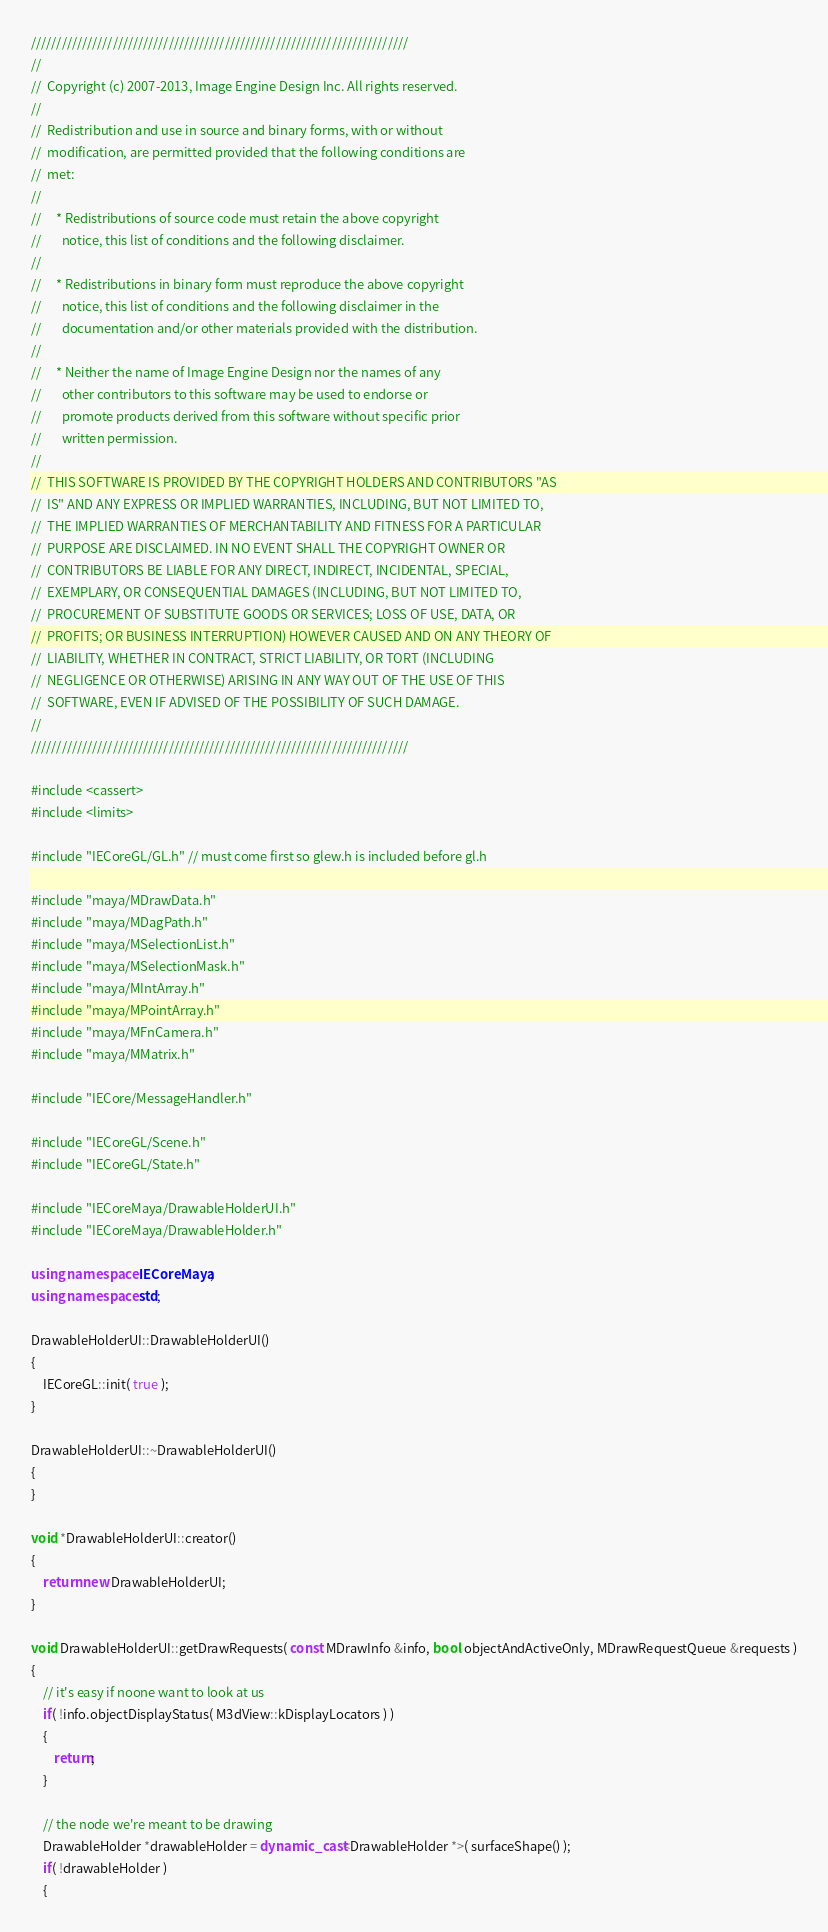<code> <loc_0><loc_0><loc_500><loc_500><_C++_>//////////////////////////////////////////////////////////////////////////
//
//  Copyright (c) 2007-2013, Image Engine Design Inc. All rights reserved.
//
//  Redistribution and use in source and binary forms, with or without
//  modification, are permitted provided that the following conditions are
//  met:
//
//     * Redistributions of source code must retain the above copyright
//       notice, this list of conditions and the following disclaimer.
//
//     * Redistributions in binary form must reproduce the above copyright
//       notice, this list of conditions and the following disclaimer in the
//       documentation and/or other materials provided with the distribution.
//
//     * Neither the name of Image Engine Design nor the names of any
//       other contributors to this software may be used to endorse or
//       promote products derived from this software without specific prior
//       written permission.
//
//  THIS SOFTWARE IS PROVIDED BY THE COPYRIGHT HOLDERS AND CONTRIBUTORS "AS
//  IS" AND ANY EXPRESS OR IMPLIED WARRANTIES, INCLUDING, BUT NOT LIMITED TO,
//  THE IMPLIED WARRANTIES OF MERCHANTABILITY AND FITNESS FOR A PARTICULAR
//  PURPOSE ARE DISCLAIMED. IN NO EVENT SHALL THE COPYRIGHT OWNER OR
//  CONTRIBUTORS BE LIABLE FOR ANY DIRECT, INDIRECT, INCIDENTAL, SPECIAL,
//  EXEMPLARY, OR CONSEQUENTIAL DAMAGES (INCLUDING, BUT NOT LIMITED TO,
//  PROCUREMENT OF SUBSTITUTE GOODS OR SERVICES; LOSS OF USE, DATA, OR
//  PROFITS; OR BUSINESS INTERRUPTION) HOWEVER CAUSED AND ON ANY THEORY OF
//  LIABILITY, WHETHER IN CONTRACT, STRICT LIABILITY, OR TORT (INCLUDING
//  NEGLIGENCE OR OTHERWISE) ARISING IN ANY WAY OUT OF THE USE OF THIS
//  SOFTWARE, EVEN IF ADVISED OF THE POSSIBILITY OF SUCH DAMAGE.
//
//////////////////////////////////////////////////////////////////////////

#include <cassert>
#include <limits>

#include "IECoreGL/GL.h" // must come first so glew.h is included before gl.h

#include "maya/MDrawData.h"
#include "maya/MDagPath.h"
#include "maya/MSelectionList.h"
#include "maya/MSelectionMask.h"
#include "maya/MIntArray.h"
#include "maya/MPointArray.h"
#include "maya/MFnCamera.h"
#include "maya/MMatrix.h"

#include "IECore/MessageHandler.h"

#include "IECoreGL/Scene.h"
#include "IECoreGL/State.h"

#include "IECoreMaya/DrawableHolderUI.h"
#include "IECoreMaya/DrawableHolder.h"

using namespace IECoreMaya;
using namespace std;

DrawableHolderUI::DrawableHolderUI()
{
	IECoreGL::init( true );
}

DrawableHolderUI::~DrawableHolderUI()
{
}

void *DrawableHolderUI::creator()
{
	return new DrawableHolderUI;
}

void DrawableHolderUI::getDrawRequests( const MDrawInfo &info, bool objectAndActiveOnly, MDrawRequestQueue &requests )
{
	// it's easy if noone want to look at us
	if( !info.objectDisplayStatus( M3dView::kDisplayLocators ) )
	{
		return;
	}
	
	// the node we're meant to be drawing
	DrawableHolder *drawableHolder = dynamic_cast<DrawableHolder *>( surfaceShape() );
	if( !drawableHolder )
	{</code> 